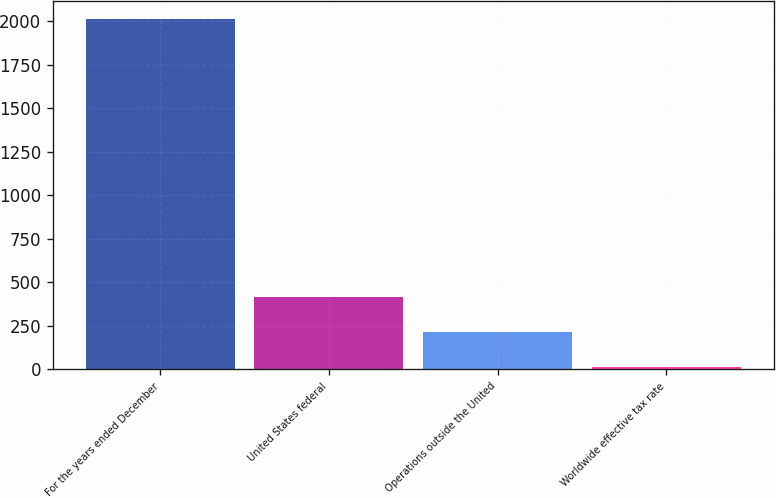<chart> <loc_0><loc_0><loc_500><loc_500><bar_chart><fcel>For the years ended December<fcel>United States federal<fcel>Operations outside the United<fcel>Worldwide effective tax rate<nl><fcel>2015<fcel>414.2<fcel>214.1<fcel>14<nl></chart> 